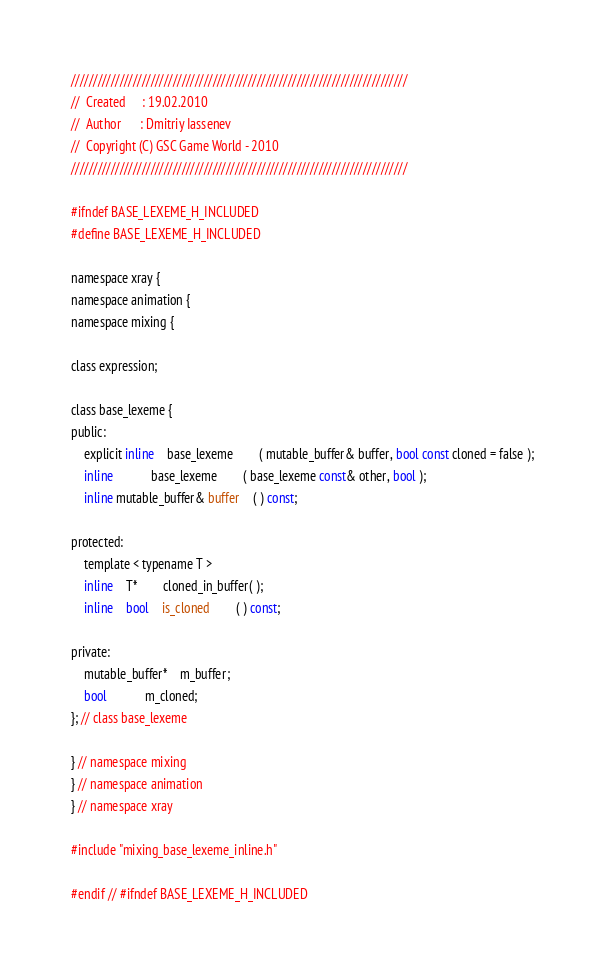Convert code to text. <code><loc_0><loc_0><loc_500><loc_500><_C_>////////////////////////////////////////////////////////////////////////////
//	Created		: 19.02.2010
//	Author		: Dmitriy Iassenev
//	Copyright (C) GSC Game World - 2010
////////////////////////////////////////////////////////////////////////////

#ifndef BASE_LEXEME_H_INCLUDED
#define BASE_LEXEME_H_INCLUDED

namespace xray {
namespace animation {
namespace mixing {

class expression;

class base_lexeme {
public:
	explicit inline	base_lexeme		( mutable_buffer& buffer, bool const cloned = false );
	inline			base_lexeme		( base_lexeme const& other, bool );
	inline mutable_buffer& buffer	( ) const;

protected:
	template < typename T >
	inline	T*		cloned_in_buffer( );
	inline	bool	is_cloned		( ) const;

private:
	mutable_buffer*	m_buffer;
	bool			m_cloned;
}; // class base_lexeme

} // namespace mixing
} // namespace animation
} // namespace xray

#include "mixing_base_lexeme_inline.h"

#endif // #ifndef BASE_LEXEME_H_INCLUDED</code> 